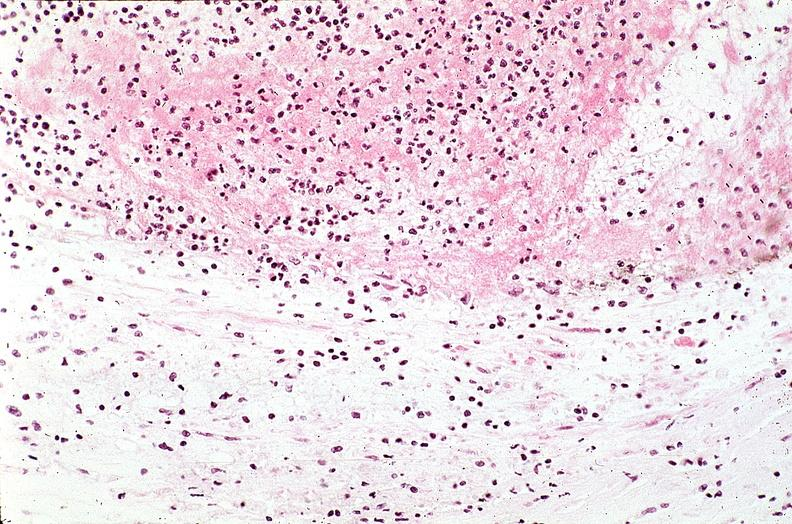what is present?
Answer the question using a single word or phrase. Vasculature 